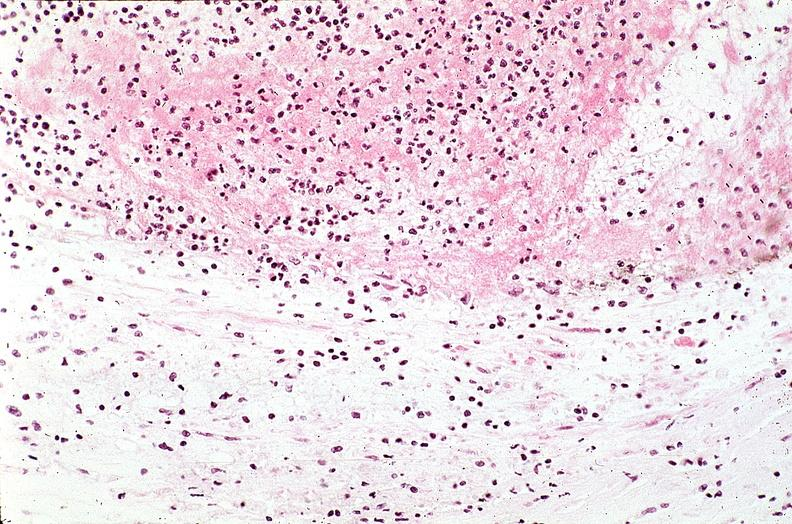what is present?
Answer the question using a single word or phrase. Vasculature 